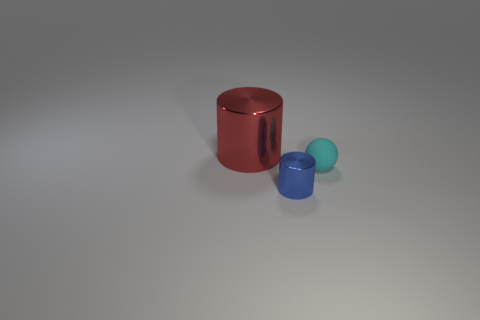Subtract 1 cylinders. How many cylinders are left? 1 Subtract all balls. How many objects are left? 2 Subtract all blue cylinders. How many cylinders are left? 1 Subtract 0 yellow cylinders. How many objects are left? 3 Subtract all blue spheres. Subtract all blue blocks. How many spheres are left? 1 Subtract all cyan balls. How many blue cylinders are left? 1 Subtract all tiny blue metal spheres. Subtract all small shiny things. How many objects are left? 2 Add 3 blue things. How many blue things are left? 4 Add 2 shiny objects. How many shiny objects exist? 4 Add 3 yellow spheres. How many objects exist? 6 